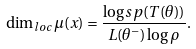Convert formula to latex. <formula><loc_0><loc_0><loc_500><loc_500>\dim _ { l o c } \mu ( x ) = \frac { \log s p ( T ( \theta ) ) } { L ( \theta ^ { - } ) \log \rho } .</formula> 